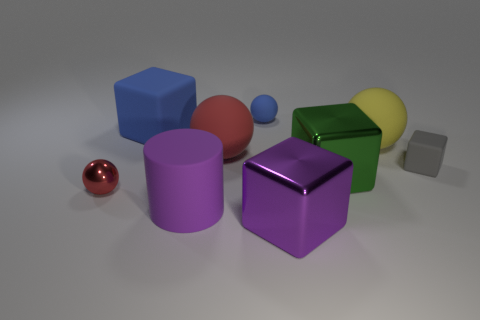How many big objects are metal objects or purple blocks?
Provide a short and direct response. 2. How many small gray things are to the left of the blue ball?
Your answer should be compact. 0. Are there any big rubber things of the same color as the tiny metallic thing?
Your answer should be very brief. Yes. There is a red metal object that is the same size as the blue ball; what is its shape?
Your answer should be very brief. Sphere. How many green things are metal cubes or cubes?
Your response must be concise. 1. What number of gray blocks have the same size as the purple rubber object?
Your answer should be very brief. 0. The thing that is the same color as the big matte cube is what shape?
Your answer should be compact. Sphere. How many things are large brown matte objects or matte things that are behind the yellow matte object?
Your answer should be very brief. 2. There is a blue matte object behind the big blue thing; is it the same size as the red object that is to the right of the large blue object?
Ensure brevity in your answer.  No. What number of green metal objects are the same shape as the purple metal thing?
Your answer should be compact. 1. 